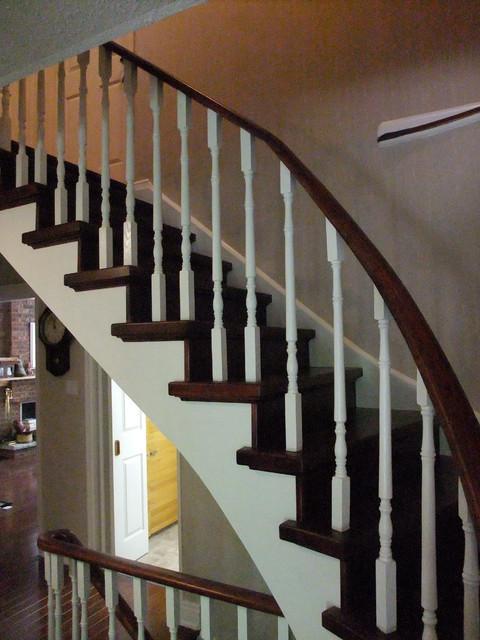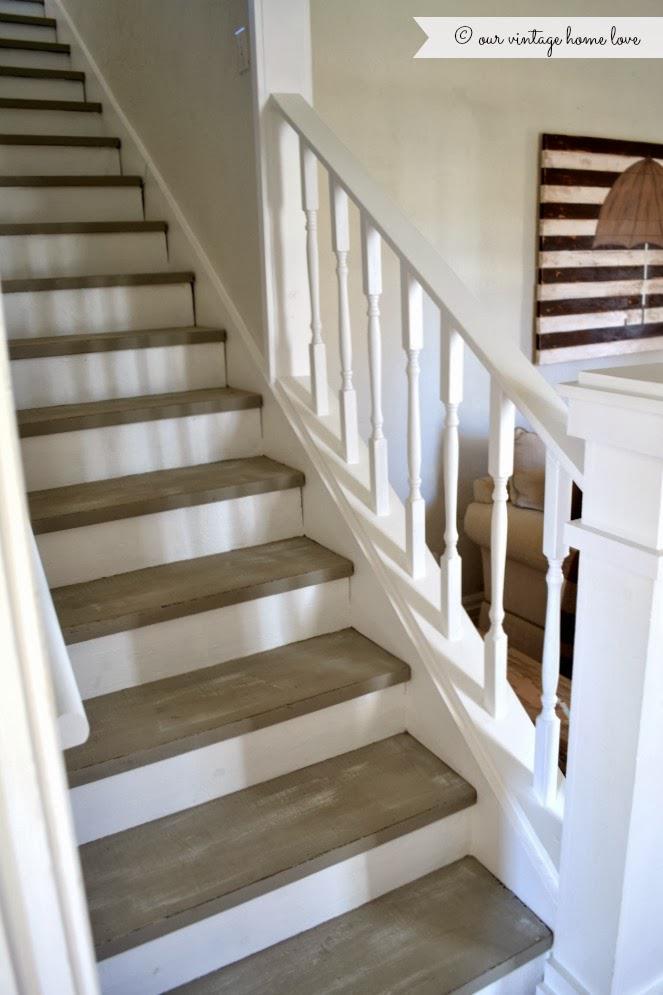The first image is the image on the left, the second image is the image on the right. Assess this claim about the two images: "There are at least two l-shaped staircases.". Correct or not? Answer yes or no. No. 